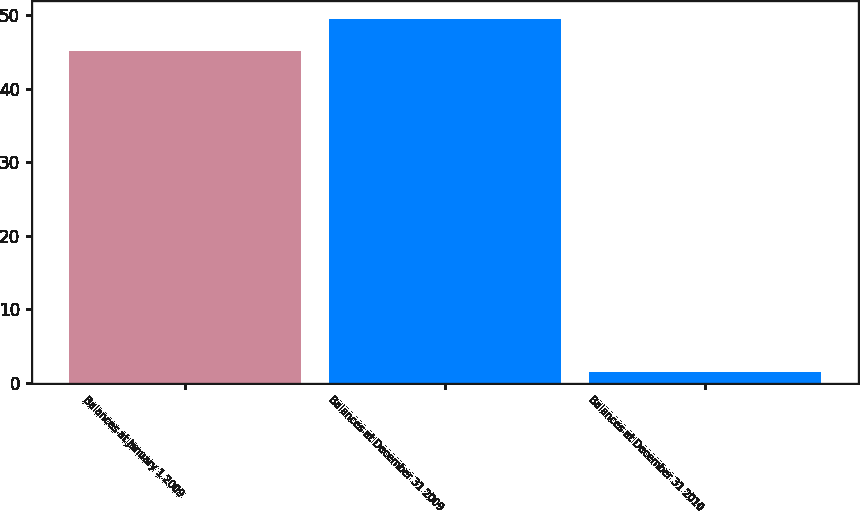<chart> <loc_0><loc_0><loc_500><loc_500><bar_chart><fcel>Balances at January 1 2009<fcel>Balances at December 31 2009<fcel>Balances at December 31 2010<nl><fcel>45.1<fcel>49.46<fcel>1.5<nl></chart> 